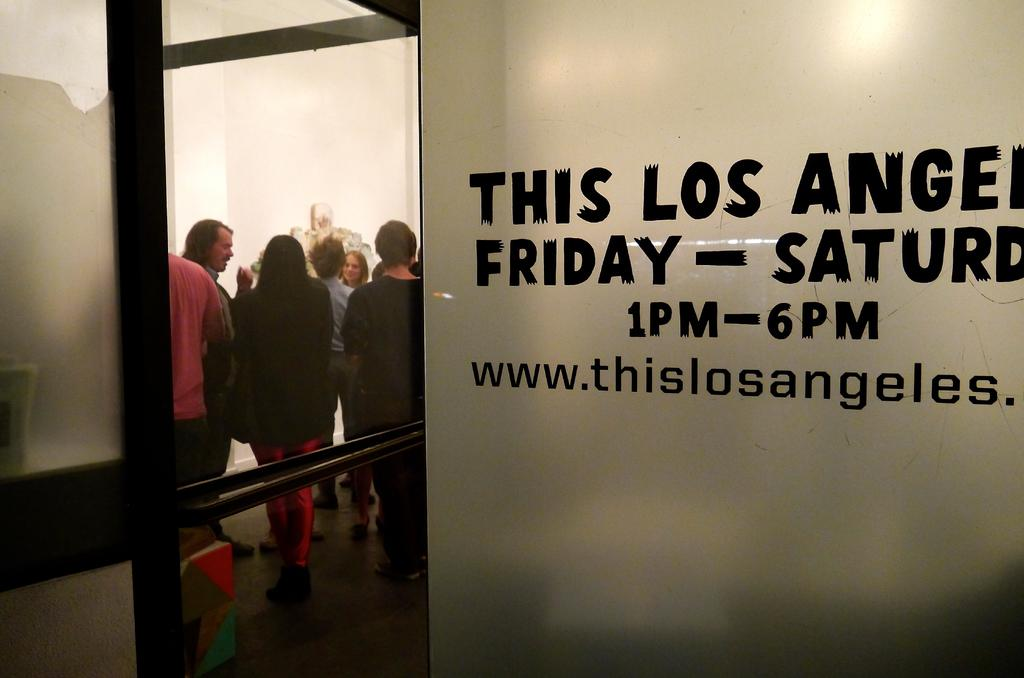<image>
Offer a succinct explanation of the picture presented. People standing inside a builing with a schedule on a wall that says 1PM - 6PM. 